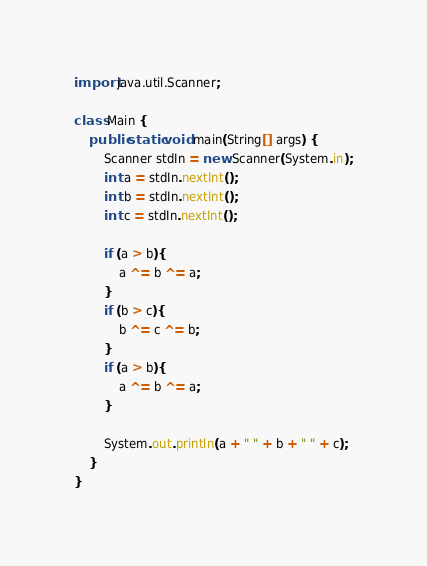<code> <loc_0><loc_0><loc_500><loc_500><_Java_>import java.util.Scanner;

class Main {
    public static void main(String[] args) {
        Scanner stdIn = new Scanner(System.in);
        int a = stdIn.nextInt();
        int b = stdIn.nextInt();
        int c = stdIn.nextInt();

        if (a > b){
            a ^= b ^= a;
        }
        if (b > c){
            b ^= c ^= b;
        }
        if (a > b){
            a ^= b ^= a;
        }

        System.out.println(a + " " + b + " " + c);
    }
}</code> 